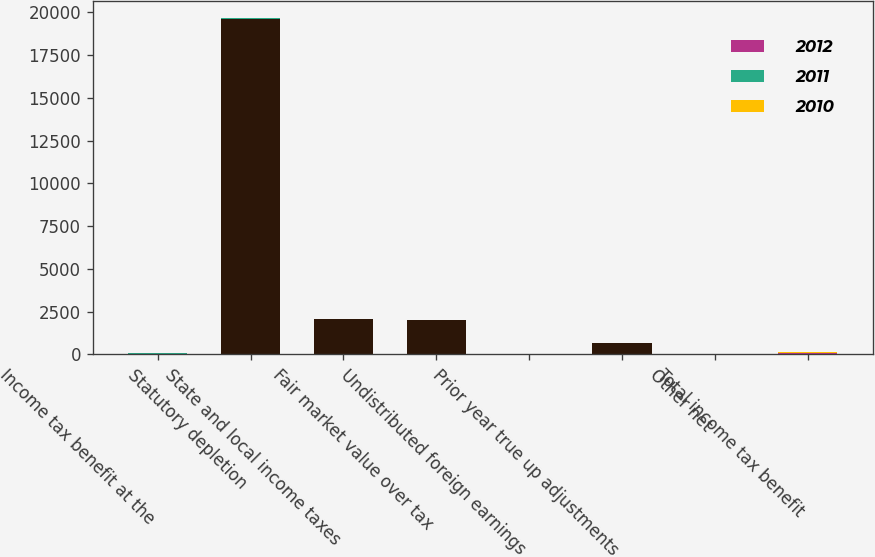<chart> <loc_0><loc_0><loc_500><loc_500><stacked_bar_chart><ecel><fcel>Income tax benefit at the<fcel>Statutory depletion<fcel>State and local income taxes<fcel>Fair market value over tax<fcel>Undistributed foreign earnings<fcel>Prior year true up adjustments<fcel>Other net<fcel>Total income tax benefit<nl><fcel>nan<fcel>2.05<fcel>19608<fcel>2076<fcel>2007<fcel>0<fcel>657<fcel>2<fcel>2.05<nl><fcel>2012<fcel>35<fcel>16.3<fcel>1.7<fcel>1.7<fcel>0<fcel>0.5<fcel>0<fcel>55.2<nl><fcel>2011<fcel>35<fcel>12.3<fcel>4.2<fcel>0<fcel>1.7<fcel>2.1<fcel>0.1<fcel>51<nl><fcel>2010<fcel>35<fcel>10.6<fcel>1.8<fcel>1.7<fcel>1.7<fcel>0.6<fcel>1.2<fcel>46.6<nl></chart> 